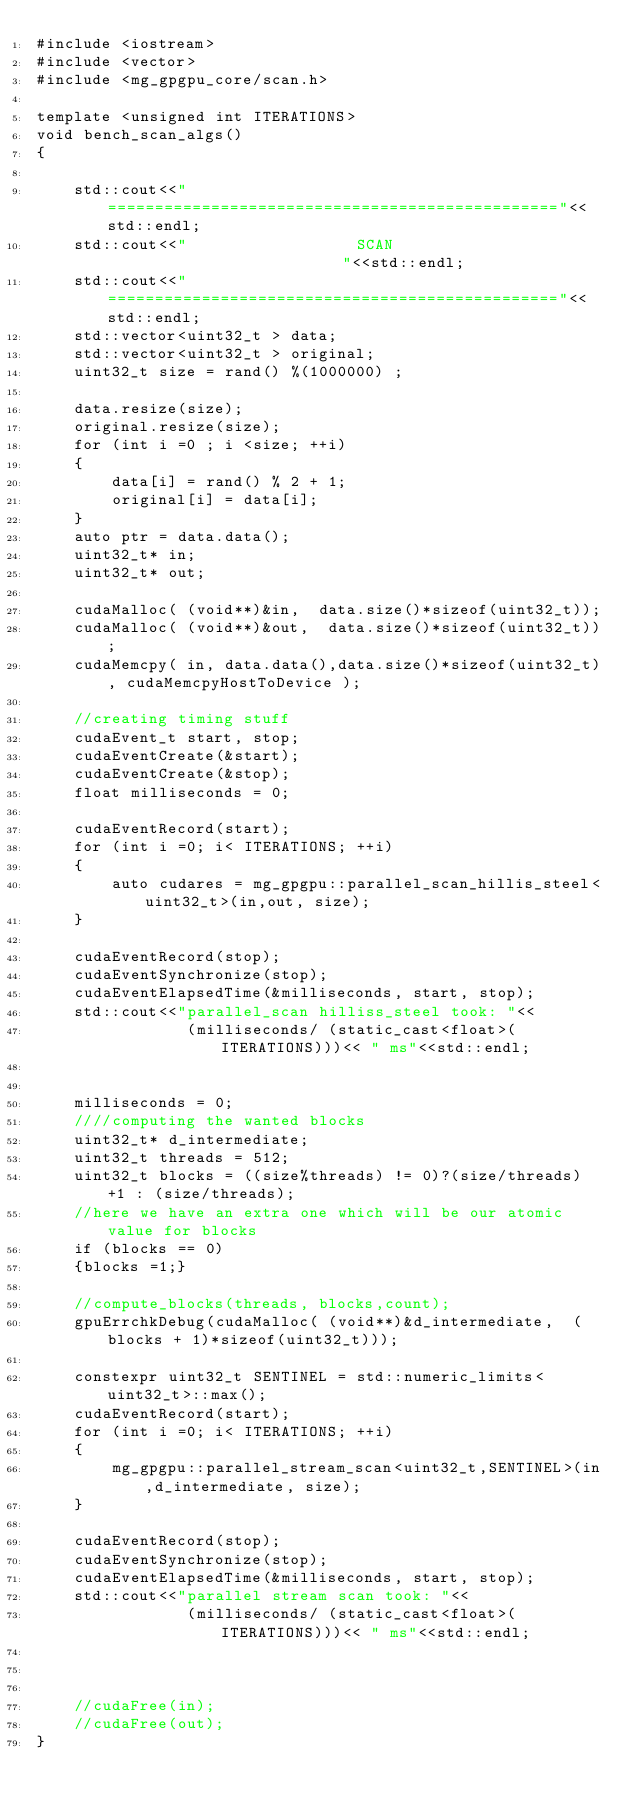Convert code to text. <code><loc_0><loc_0><loc_500><loc_500><_Cuda_>#include <iostream>
#include <vector>
#include <mg_gpgpu_core/scan.h>

template <unsigned int ITERATIONS>
void bench_scan_algs()
{

    std::cout<<"================================================"<<std::endl;
    std::cout<<"                  SCAN                          "<<std::endl;
    std::cout<<"================================================"<<std::endl;
    std::vector<uint32_t > data;
    std::vector<uint32_t > original;
    uint32_t size = rand() %(1000000) ;

    data.resize(size);
    original.resize(size);
    for (int i =0 ; i <size; ++i)
    {
        data[i] = rand() % 2 + 1;
        original[i] = data[i];
    }
    auto ptr = data.data();
    uint32_t* in;
    uint32_t* out;

    cudaMalloc( (void**)&in,  data.size()*sizeof(uint32_t));
    cudaMalloc( (void**)&out,  data.size()*sizeof(uint32_t));
    cudaMemcpy( in, data.data(),data.size()*sizeof(uint32_t), cudaMemcpyHostToDevice );

    //creating timing stuff
    cudaEvent_t start, stop;
    cudaEventCreate(&start);
    cudaEventCreate(&stop);    
    float milliseconds = 0;

    cudaEventRecord(start);
    for (int i =0; i< ITERATIONS; ++i)
    {
        auto cudares = mg_gpgpu::parallel_scan_hillis_steel<uint32_t>(in,out, size);
    }

    cudaEventRecord(stop);
    cudaEventSynchronize(stop);
    cudaEventElapsedTime(&milliseconds, start, stop);
    std::cout<<"parallel_scan hilliss_steel took: "<<
                (milliseconds/ (static_cast<float>(ITERATIONS)))<< " ms"<<std::endl;


    milliseconds = 0;
    ////computing the wanted blocks
    uint32_t* d_intermediate;
    uint32_t threads = 512;
    uint32_t blocks = ((size%threads) != 0)?(size/threads) +1 : (size/threads);
    //here we have an extra one which will be our atomic value for blocks
    if (blocks == 0)
    {blocks =1;}

    //compute_blocks(threads, blocks,count);
    gpuErrchkDebug(cudaMalloc( (void**)&d_intermediate,  (blocks + 1)*sizeof(uint32_t)));

    constexpr uint32_t SENTINEL = std::numeric_limits<uint32_t>::max();
    cudaEventRecord(start);
    for (int i =0; i< ITERATIONS; ++i)
    {
        mg_gpgpu::parallel_stream_scan<uint32_t,SENTINEL>(in,d_intermediate, size);
    }

    cudaEventRecord(stop);
    cudaEventSynchronize(stop);
    cudaEventElapsedTime(&milliseconds, start, stop);
    std::cout<<"parallel stream scan took: "<<
                (milliseconds/ (static_cast<float>(ITERATIONS)))<< " ms"<<std::endl;



    //cudaFree(in);
    //cudaFree(out);
}
</code> 